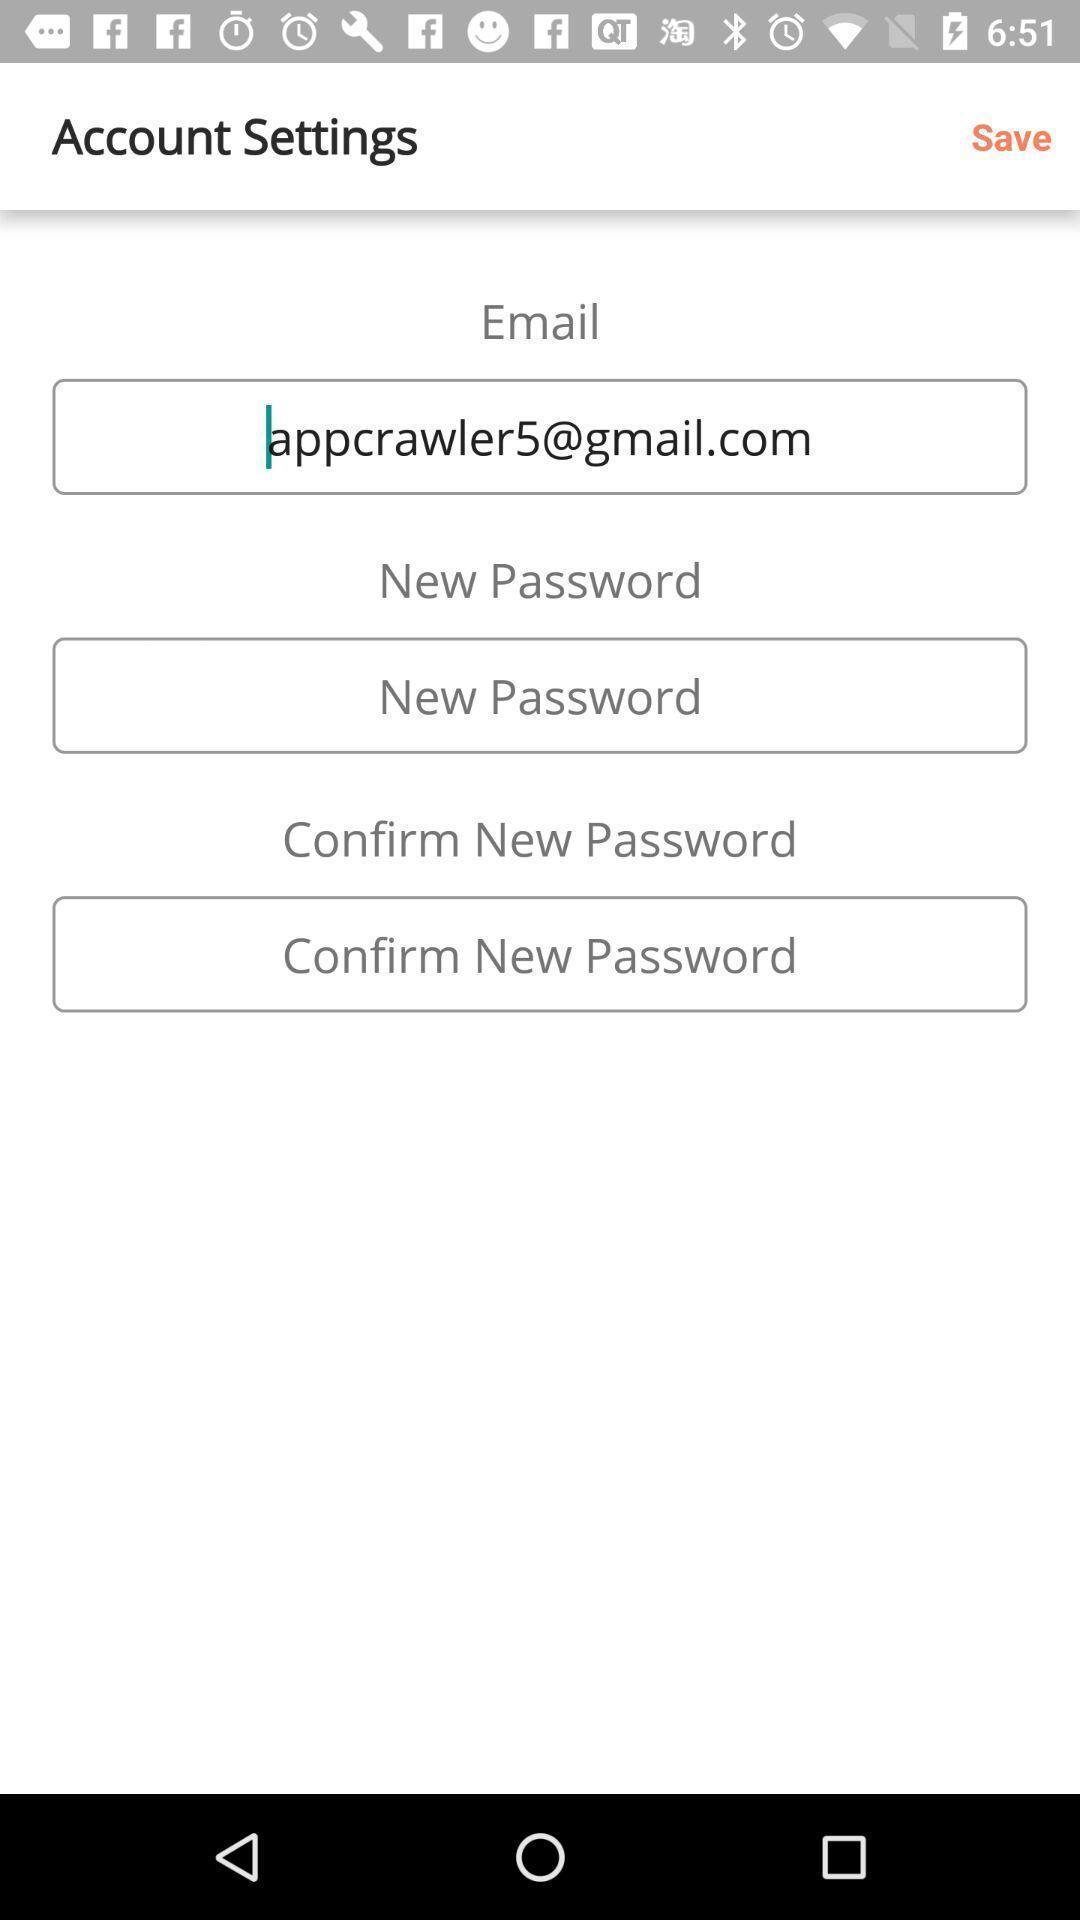Tell me what you see in this picture. Screen displaying user profile information in a shopping application. 